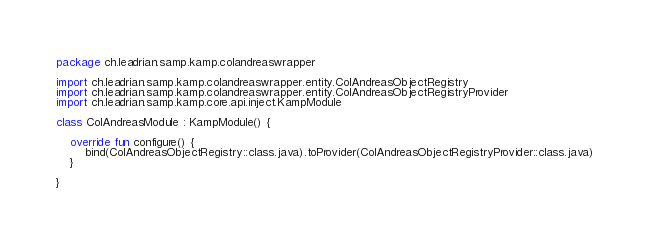<code> <loc_0><loc_0><loc_500><loc_500><_Kotlin_>package ch.leadrian.samp.kamp.colandreaswrapper

import ch.leadrian.samp.kamp.colandreaswrapper.entity.ColAndreasObjectRegistry
import ch.leadrian.samp.kamp.colandreaswrapper.entity.ColAndreasObjectRegistryProvider
import ch.leadrian.samp.kamp.core.api.inject.KampModule

class ColAndreasModule : KampModule() {

    override fun configure() {
        bind(ColAndreasObjectRegistry::class.java).toProvider(ColAndreasObjectRegistryProvider::class.java)
    }

}</code> 